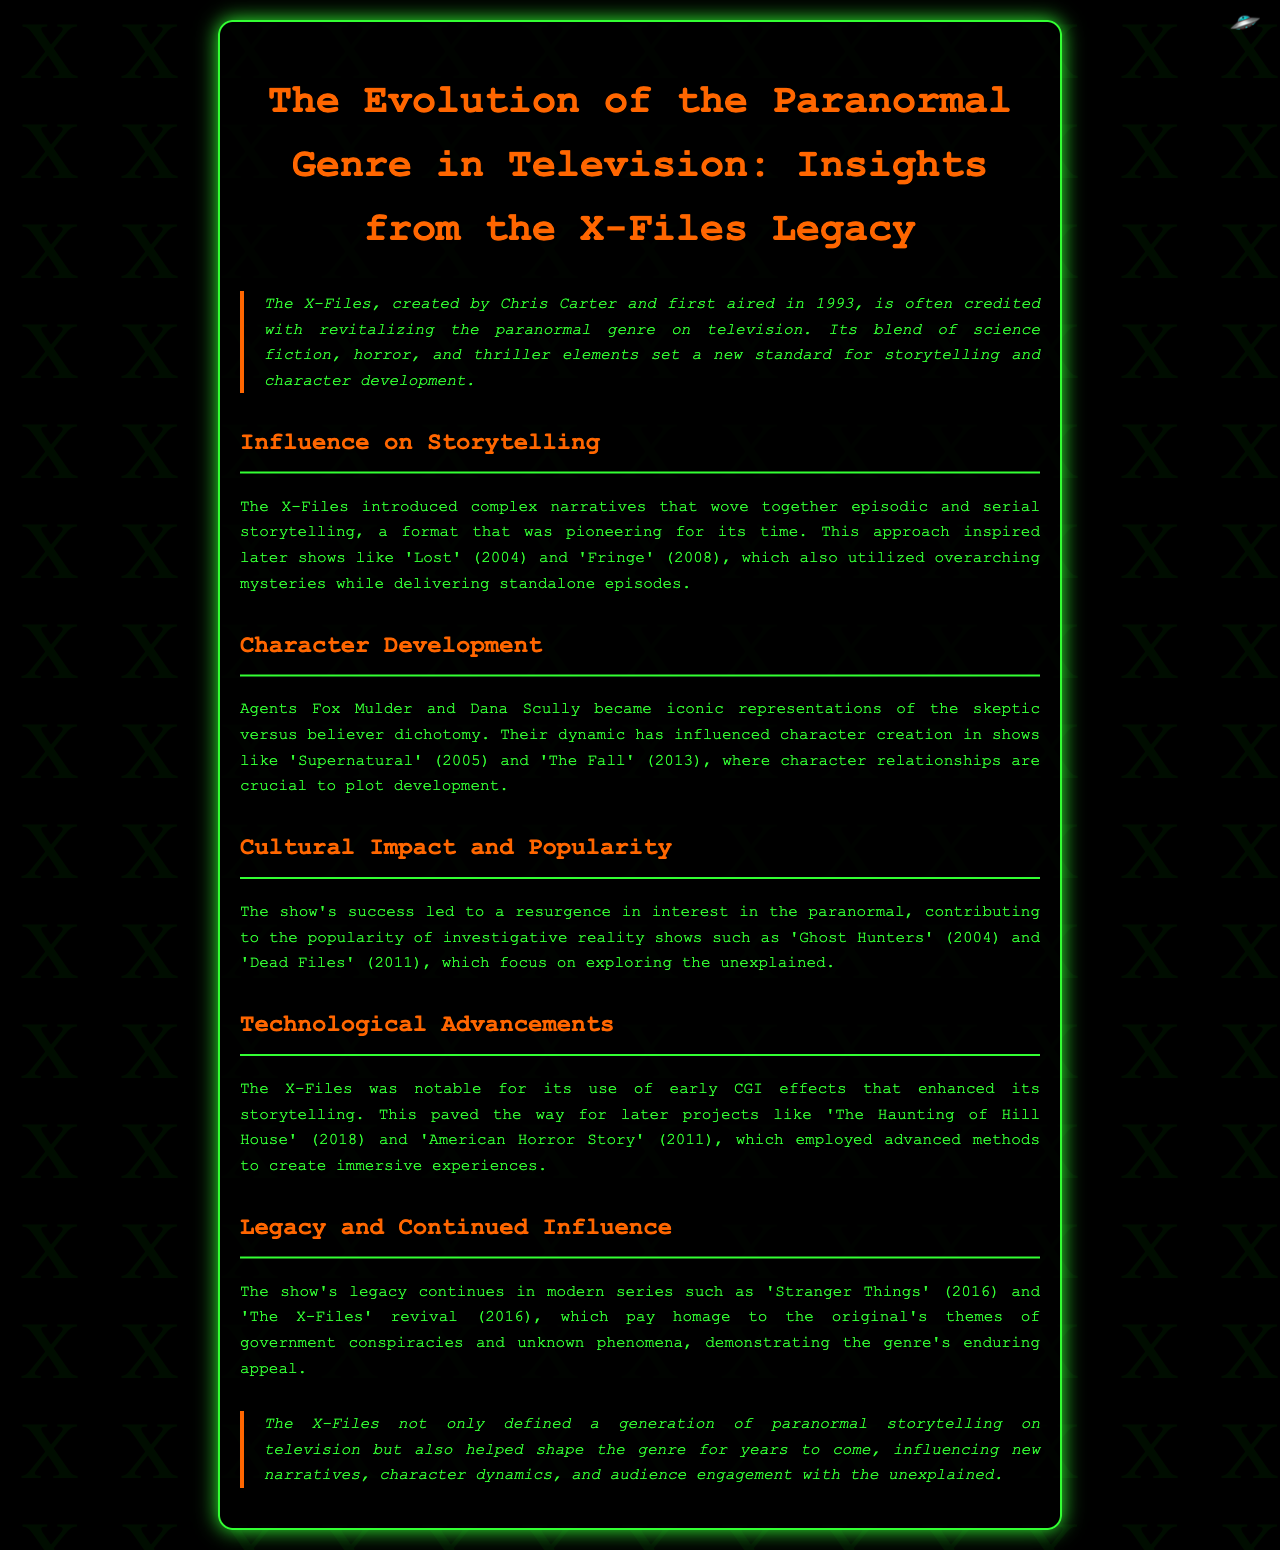What year did The X-Files first air? The document specifies the first airing year of The X-Files as 1993.
Answer: 1993 Who created The X-Files? The report mentions Chris Carter as the creator of The X-Files.
Answer: Chris Carter Which two agents are central to The X-Files? The document refers to Agents Fox Mulder and Dana Scully as key characters.
Answer: Fox Mulder and Dana Scully What genre did The X-Files help revive? The focus of the document is on the paranormal genre in television.
Answer: Paranormal genre Which show is mentioned as influencing 'Lost'? The document notes that The X-Files inspired later shows, including 'Lost'.
Answer: The X-Files What narrative style did The X-Files pioneer? The document highlights the combination of episodic and serial storytelling as a major narrative style introduced.
Answer: Episodic and serial storytelling In which year was 'Stranger Things' released? The report lists the release year of 'Stranger Things' as 2016.
Answer: 2016 What was noted about the technological aspect of The X-Files? The document emphasizes The X-Files' use of early CGI effects significantly enhancing the storytelling.
Answer: Early CGI effects Which two shows focus on exploring the unexplained due to The X-Files' influence? The text mentions 'Ghost Hunters' and 'Dead Files' as shows that gained popularity due to The X-Files.
Answer: Ghost Hunters and Dead Files 